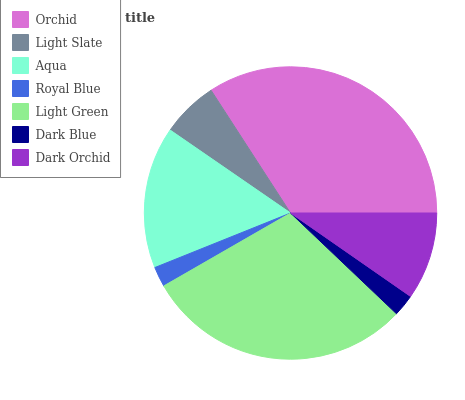Is Royal Blue the minimum?
Answer yes or no. Yes. Is Orchid the maximum?
Answer yes or no. Yes. Is Light Slate the minimum?
Answer yes or no. No. Is Light Slate the maximum?
Answer yes or no. No. Is Orchid greater than Light Slate?
Answer yes or no. Yes. Is Light Slate less than Orchid?
Answer yes or no. Yes. Is Light Slate greater than Orchid?
Answer yes or no. No. Is Orchid less than Light Slate?
Answer yes or no. No. Is Dark Orchid the high median?
Answer yes or no. Yes. Is Dark Orchid the low median?
Answer yes or no. Yes. Is Orchid the high median?
Answer yes or no. No. Is Light Slate the low median?
Answer yes or no. No. 